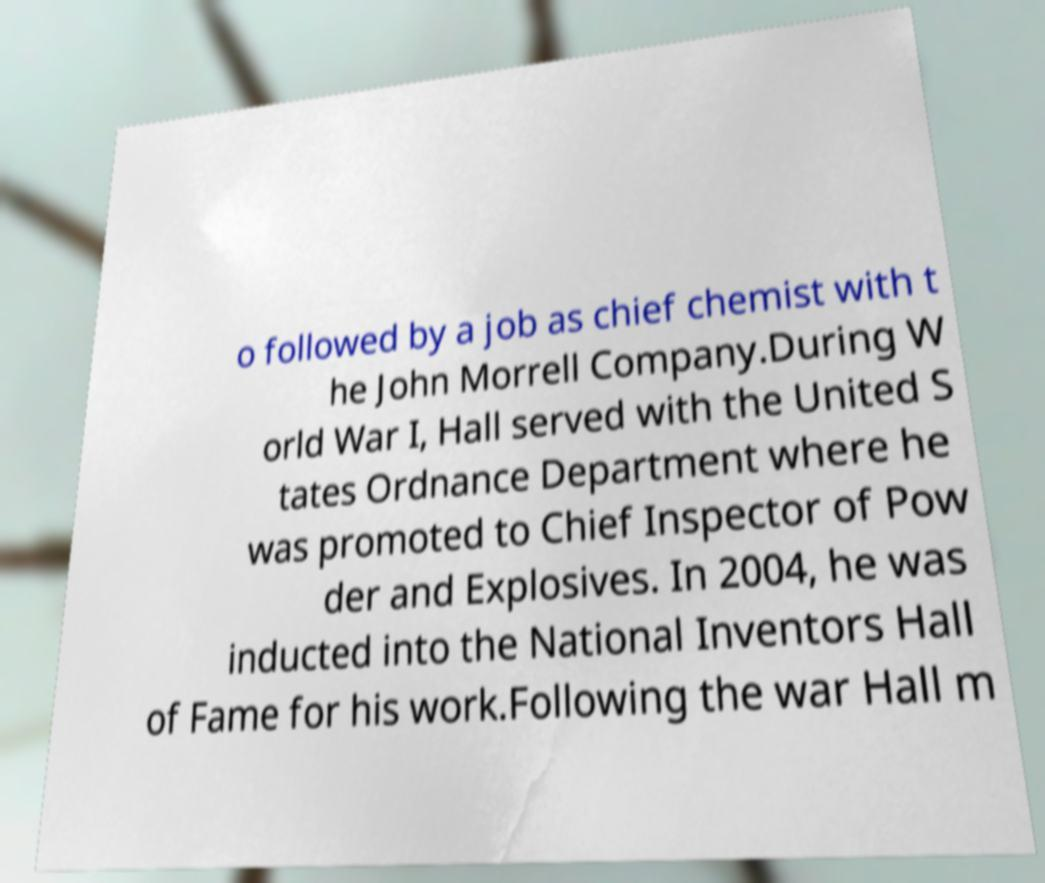For documentation purposes, I need the text within this image transcribed. Could you provide that? o followed by a job as chief chemist with t he John Morrell Company.During W orld War I, Hall served with the United S tates Ordnance Department where he was promoted to Chief Inspector of Pow der and Explosives. In 2004, he was inducted into the National Inventors Hall of Fame for his work.Following the war Hall m 